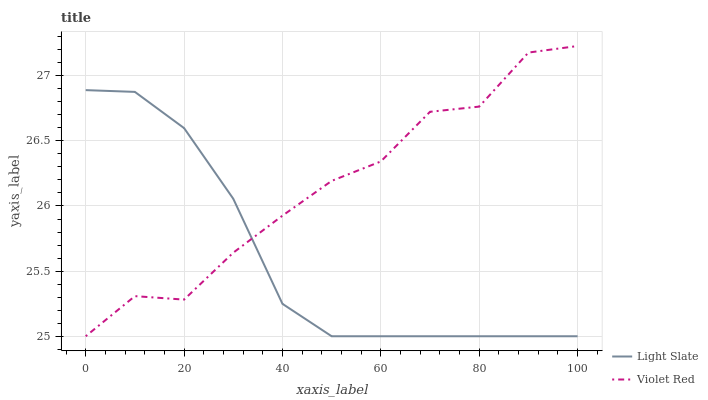Does Light Slate have the minimum area under the curve?
Answer yes or no. Yes. Does Violet Red have the maximum area under the curve?
Answer yes or no. Yes. Does Violet Red have the minimum area under the curve?
Answer yes or no. No. Is Light Slate the smoothest?
Answer yes or no. Yes. Is Violet Red the roughest?
Answer yes or no. Yes. Is Violet Red the smoothest?
Answer yes or no. No. Does Light Slate have the lowest value?
Answer yes or no. Yes. Does Violet Red have the highest value?
Answer yes or no. Yes. Does Violet Red intersect Light Slate?
Answer yes or no. Yes. Is Violet Red less than Light Slate?
Answer yes or no. No. Is Violet Red greater than Light Slate?
Answer yes or no. No. 